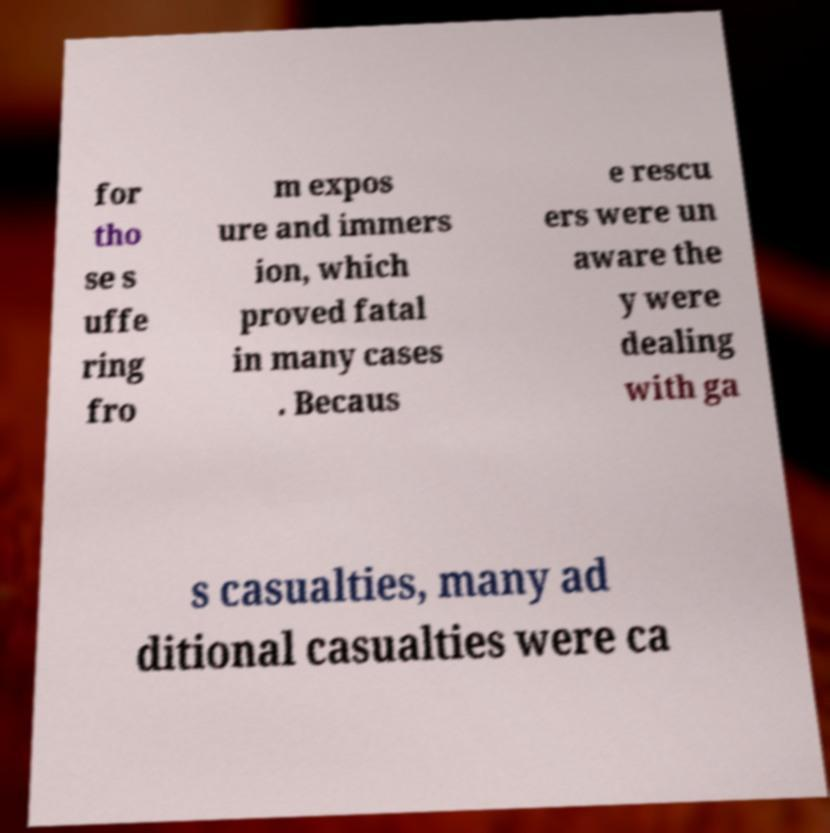Could you extract and type out the text from this image? for tho se s uffe ring fro m expos ure and immers ion, which proved fatal in many cases . Becaus e rescu ers were un aware the y were dealing with ga s casualties, many ad ditional casualties were ca 